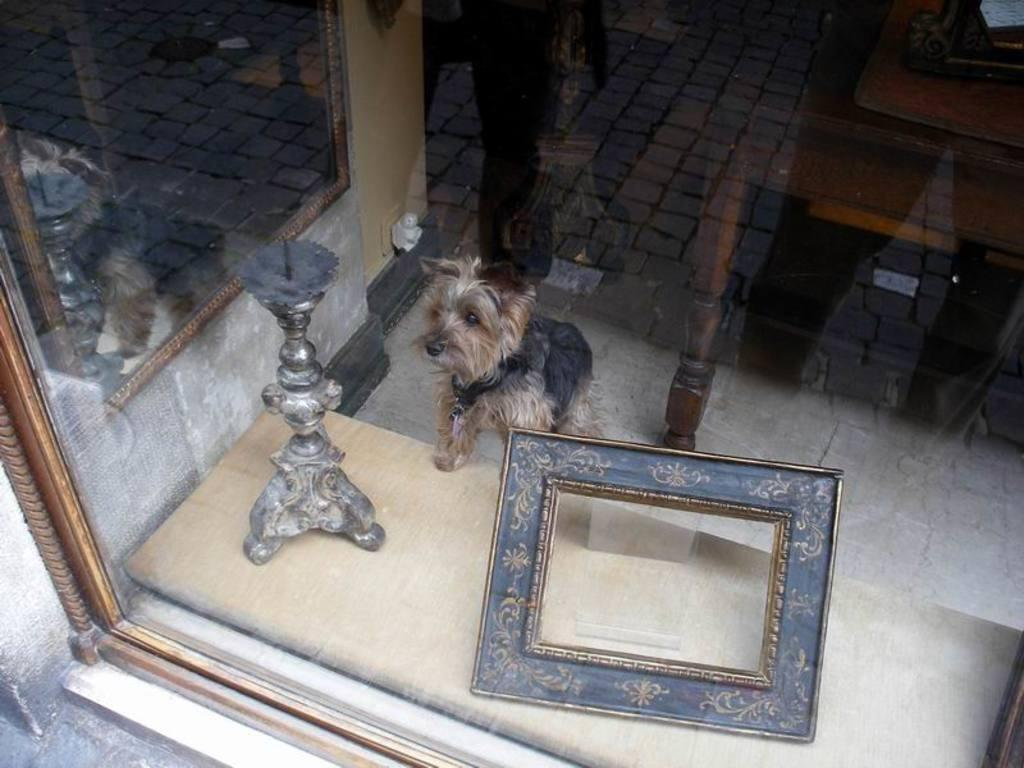What type of wall is present in the image? There is a glass wall in the image. What can be seen through the glass wall? A photo frame is visible through the glass wall. What object is present in the image that might hold something? There is a stand in the image. What animal is in the image? There is a dog present in the image. What piece of furniture is in the image? There is a table in the image. Can you see a person's reflection in the image? Yes, the reflection of a person is visible on the glass wall. How many chickens are visible on the table in the image? There are no chickens present in the image; only a dog, table, and other objects are visible. What type of wing is attached to the dog in the image? There is no wing attached to the dog in the image; it is a regular dog without any additional features. 